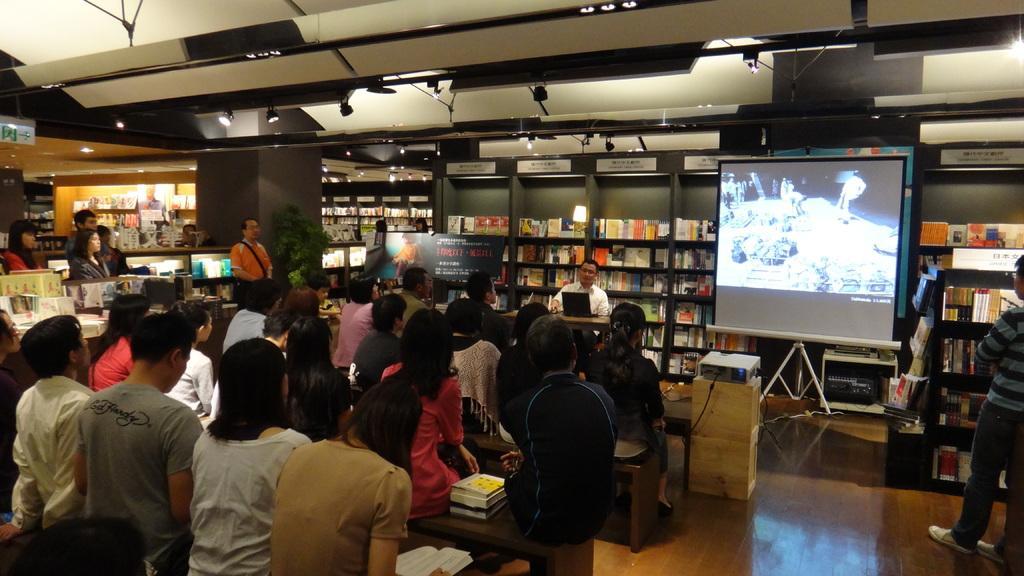Could you give a brief overview of what you see in this image? This image is taken from inside. In this image we can see there are so many people sitting on the benches, one of them is holding a book and the other one placed some books beside her, in front of them there is a person sitting on the chair in front of the table with a monitor on top of it, beside the table there is a screen and there is a projector placed on the table. In the background there are so many books arranged in the so many racks and there are labels on top of the racks. At the top of the image there is a ceiling with lights. 